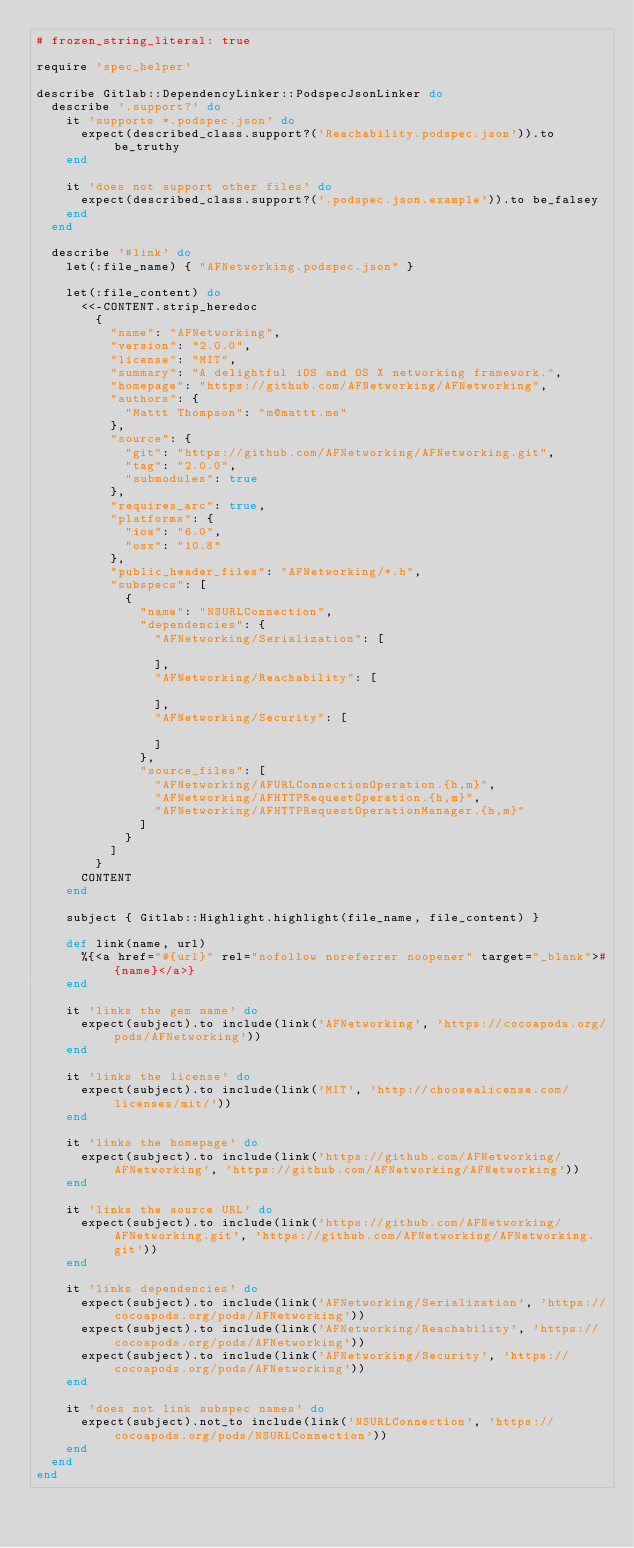<code> <loc_0><loc_0><loc_500><loc_500><_Ruby_># frozen_string_literal: true

require 'spec_helper'

describe Gitlab::DependencyLinker::PodspecJsonLinker do
  describe '.support?' do
    it 'supports *.podspec.json' do
      expect(described_class.support?('Reachability.podspec.json')).to be_truthy
    end

    it 'does not support other files' do
      expect(described_class.support?('.podspec.json.example')).to be_falsey
    end
  end

  describe '#link' do
    let(:file_name) { "AFNetworking.podspec.json" }

    let(:file_content) do
      <<-CONTENT.strip_heredoc
        {
          "name": "AFNetworking",
          "version": "2.0.0",
          "license": "MIT",
          "summary": "A delightful iOS and OS X networking framework.",
          "homepage": "https://github.com/AFNetworking/AFNetworking",
          "authors": {
            "Mattt Thompson": "m@mattt.me"
          },
          "source": {
            "git": "https://github.com/AFNetworking/AFNetworking.git",
            "tag": "2.0.0",
            "submodules": true
          },
          "requires_arc": true,
          "platforms": {
            "ios": "6.0",
            "osx": "10.8"
          },
          "public_header_files": "AFNetworking/*.h",
          "subspecs": [
            {
              "name": "NSURLConnection",
              "dependencies": {
                "AFNetworking/Serialization": [

                ],
                "AFNetworking/Reachability": [

                ],
                "AFNetworking/Security": [

                ]
              },
              "source_files": [
                "AFNetworking/AFURLConnectionOperation.{h,m}",
                "AFNetworking/AFHTTPRequestOperation.{h,m}",
                "AFNetworking/AFHTTPRequestOperationManager.{h,m}"
              ]
            }
          ]
        }
      CONTENT
    end

    subject { Gitlab::Highlight.highlight(file_name, file_content) }

    def link(name, url)
      %{<a href="#{url}" rel="nofollow noreferrer noopener" target="_blank">#{name}</a>}
    end

    it 'links the gem name' do
      expect(subject).to include(link('AFNetworking', 'https://cocoapods.org/pods/AFNetworking'))
    end

    it 'links the license' do
      expect(subject).to include(link('MIT', 'http://choosealicense.com/licenses/mit/'))
    end

    it 'links the homepage' do
      expect(subject).to include(link('https://github.com/AFNetworking/AFNetworking', 'https://github.com/AFNetworking/AFNetworking'))
    end

    it 'links the source URL' do
      expect(subject).to include(link('https://github.com/AFNetworking/AFNetworking.git', 'https://github.com/AFNetworking/AFNetworking.git'))
    end

    it 'links dependencies' do
      expect(subject).to include(link('AFNetworking/Serialization', 'https://cocoapods.org/pods/AFNetworking'))
      expect(subject).to include(link('AFNetworking/Reachability', 'https://cocoapods.org/pods/AFNetworking'))
      expect(subject).to include(link('AFNetworking/Security', 'https://cocoapods.org/pods/AFNetworking'))
    end

    it 'does not link subspec names' do
      expect(subject).not_to include(link('NSURLConnection', 'https://cocoapods.org/pods/NSURLConnection'))
    end
  end
end
</code> 